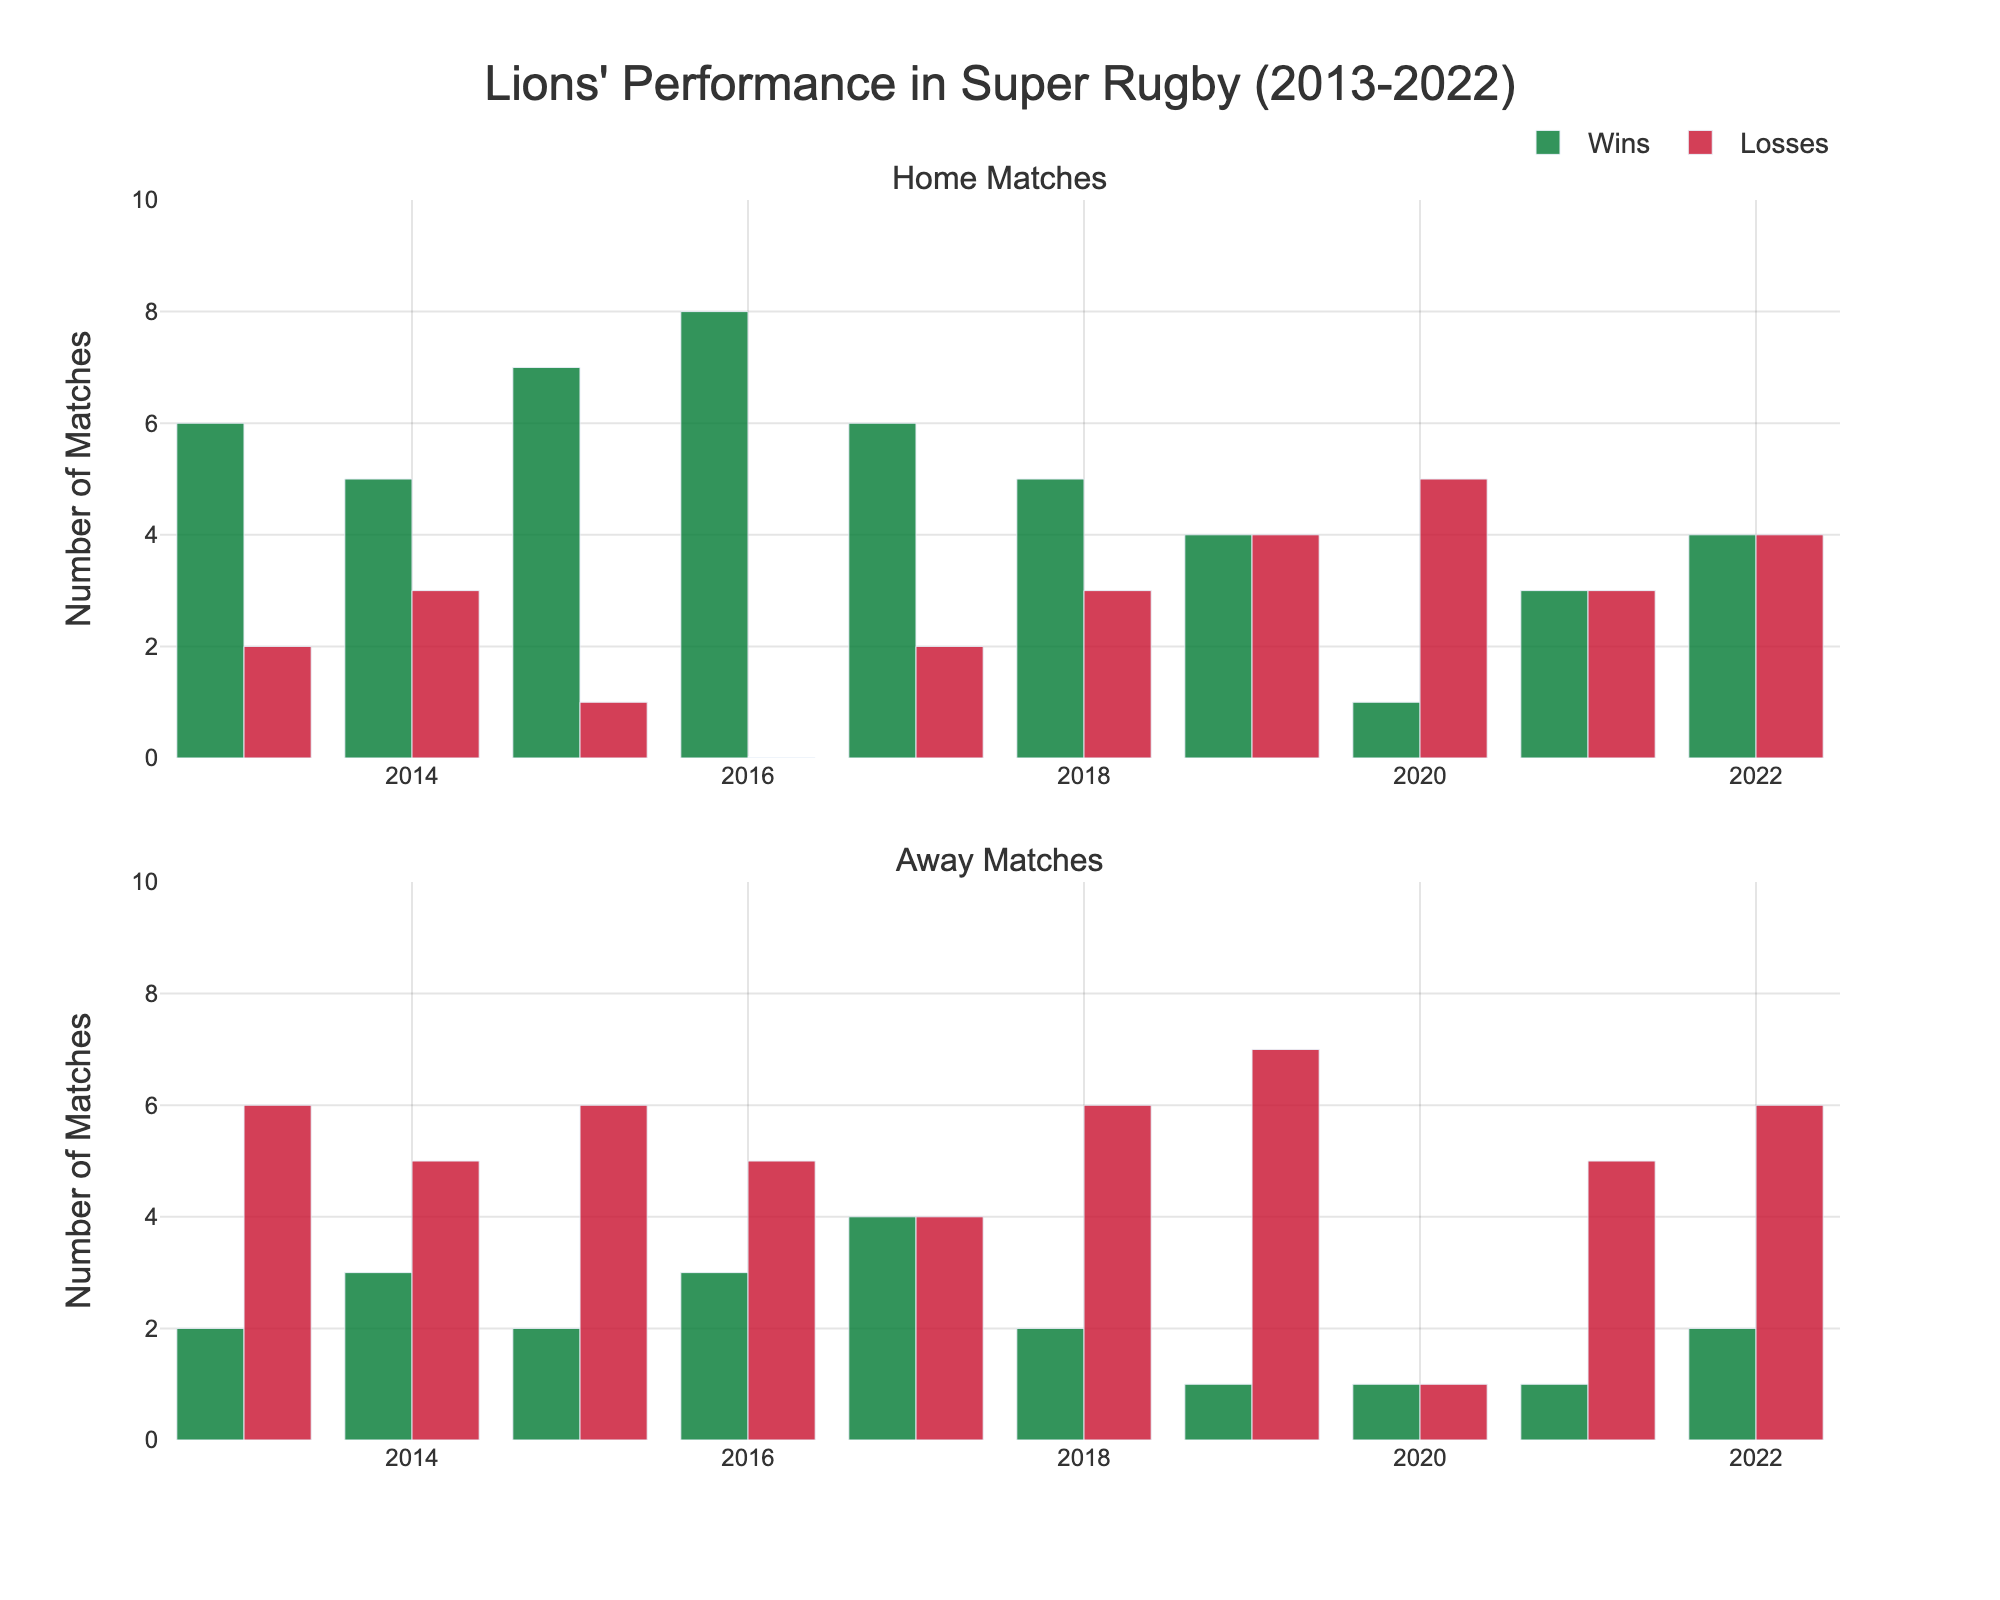Which year had the most home wins? By observing the bar heights in the "Home Matches" subplot, the tallest bar for home wins is in 2016.
Answer: 2016 Which year had the fewest away wins? By observing the bar heights in the "Away Matches" subplot, the shortest bar for away wins is in 2019, 2020, and 2021.
Answer: 2019, 2020, 2021 How many total home wins did the Lions achieve in 2017? Look at the bar for home wins in the "Home Matches" subplot for 2017. The bar's height indicates 6 wins.
Answer: 6 In which year did the Lions win more away matches than home matches? Compare the "Wins" bars for home and away matches for each year. Only in 2017 are the away wins (4) equal to the home wins (6). Therefore, there is no year where away wins exceed home wins.
Answer: None Which year had the highest combined losses for both home and away matches? Sum the heights of home losses and away losses bars for each year. In 2019, the combined losses are home (4) + away (7) = 11. This is the highest.
Answer: 2019 How did the Lions' home win record change between 2018 and 2019? Check the heights of home win bars for 2018 and 2019 in the "Home Matches" subplot. In 2018, there were 5 wins; in 2019, there were 4. The record decreased by 1 win.
Answer: Decreased by 1 win Which subplot shows more variability in win-loss records over the years? Compare the range of bar heights between "Home Matches" and "Away Matches" subplots. The "Home Matches" subplot varies from 0 to 8, while the "Away Matches" varies from 1 to 7. Home has a larger range and thus, more variability.
Answer: Home Matches In which year did the Lions have the same number of home wins and losses? Look for a year in the "Home Matches" subplot where the height of the wins and losses bars are the same. In 2019, both wins and losses are 4.
Answer: 2019 